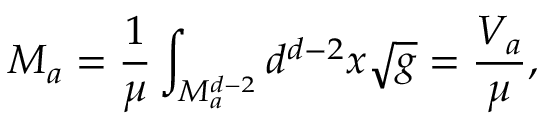Convert formula to latex. <formula><loc_0><loc_0><loc_500><loc_500>M _ { a } = \frac { 1 } { \mu } \int _ { M _ { a } ^ { d - 2 } } d ^ { d - 2 } x \sqrt { g } = \frac { V _ { a } } { \mu } ,</formula> 